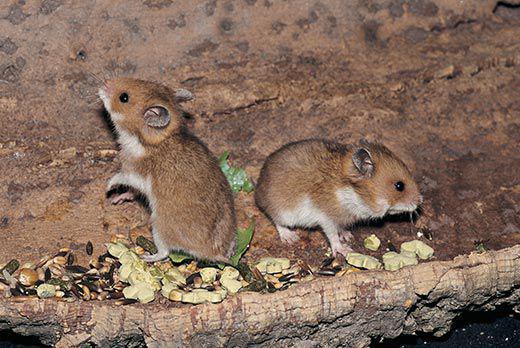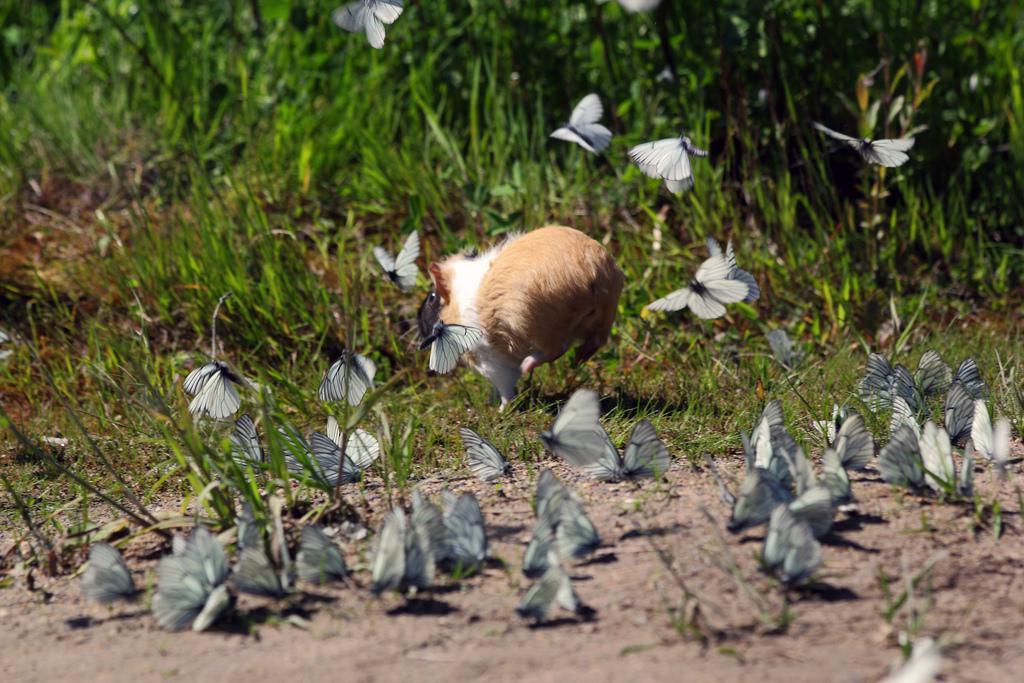The first image is the image on the left, the second image is the image on the right. Examine the images to the left and right. Is the description "There is exactly one rodent in the image on the left." accurate? Answer yes or no. No. 